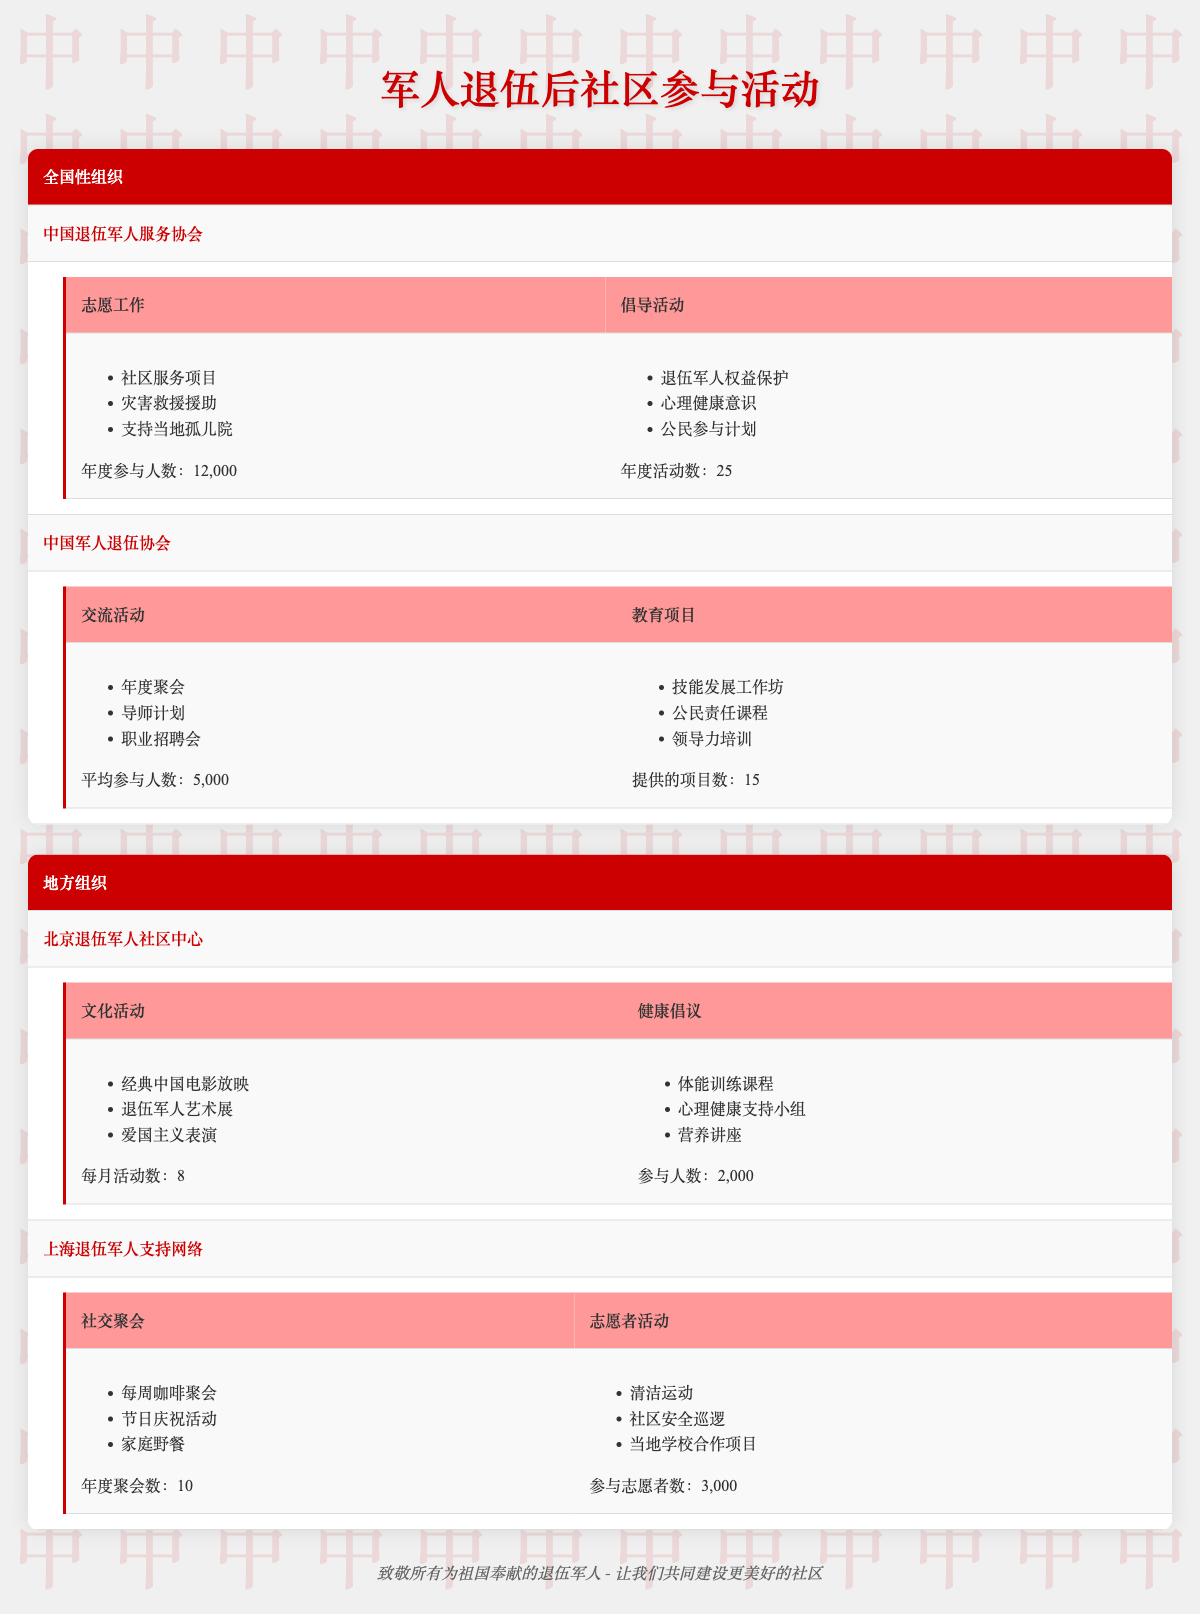What types of cultural activities are organized by the Beijing Veterans Community Center? The table lists three cultural activities under the Beijing Veterans Community Center: classic Chinese film screenings, art exhibitions by veterans, and patriotic performances. These were directly extracted from the CulturalActivities section for this community center.
Answer: Classic Chinese film screenings, art exhibitions by veterans, patriotic performances How many annual participation events are reported by the China Veterans Service Association for volunteer work? The table states that the annual participation in volunteer work for the China Veterans Service Association is 12,000. This is found directly under the VolunteerWork section of the organization.
Answer: 12,000 Which organization has an average of 5,000 attendees at their networking events? According to the table, the Chinese Military Veterans Association has an average of 5,000 attendees at their networking events, as indicated in the NetworkingEvents section of the table.
Answer: Chinese Military Veterans Association What is the total number of annual events for advocacy and volunteer work combined? For advocacy, the China Veterans Service Association has 25 annual events, and for volunteer work, the Beijing Veterans Community Center has 0 in the table. Therefore, combining these, the total is 25 + 0 = 25. The challenge here was identifying that the volunteer work value was not specified for this center and confirming the provided number.
Answer: 25 Does the Shanghai Veterans Support Network conduct any volunteer efforts? Yes, based on the table, the Shanghai Veterans Support Network conducts volunteer efforts, which include community projects like clean-up drives and neighborhood safety patrols, confirming that it is true as indicated under the VolunteerEfforts section.
Answer: Yes How many cultural activities does the Beijing Veterans Community Center organize each month? The table specifies that the Beijing Veterans Community Center organizes 8 cultural activities each month under the CulturalActivities section. This value can be found directly in the displayed information.
Answer: 8 What are the focus areas for the advocacy work of the China Veterans Service Association? The focus areas for advocacy work listed in the table are veterans' rights protection, mental health awareness, and civic engagement programs. This information can be found directly in the Advocacy section of the organization.
Answer: Veterans' rights protection, mental health awareness, civic engagement programs How many total monthly events does the Beijing Veterans Community Center and the Shanghai Veterans Support Network hold combined? The Beijing Veterans Community Center has 8 cultural activities monthly, and the Shanghai Veterans Support Network has 0 monthly events stated in the table. Thus, the total is 8 + 0 = 8. This reveals the need to check each organization's details separately before combining them.
Answer: 8 What are the programs offered by the Beijing Veterans Community Center in health initiatives? The table outlines three health initiatives: physical fitness classes, mental health support groups, and nutrition workshops. This was extracted from the HealthInitiatives section for the center.
Answer: Physical fitness classes, mental health support groups, nutrition workshops 